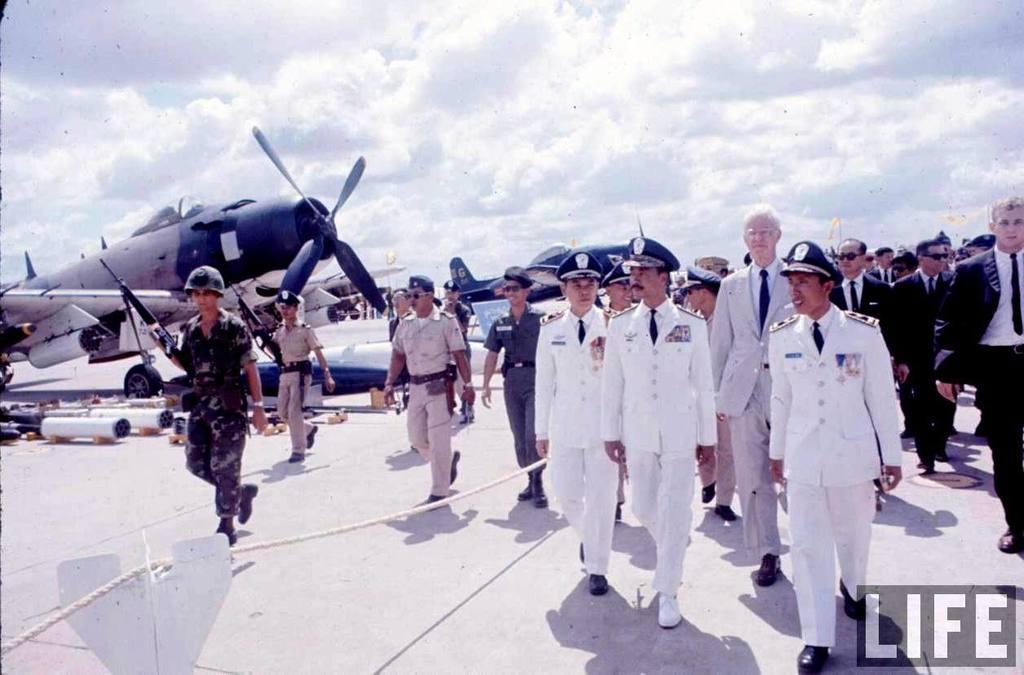Please provide a concise description of this image. In this picture there are few persons standing and there are few planes in the left corner and there is something written in the right bottom corner and the sky is cloudy. 